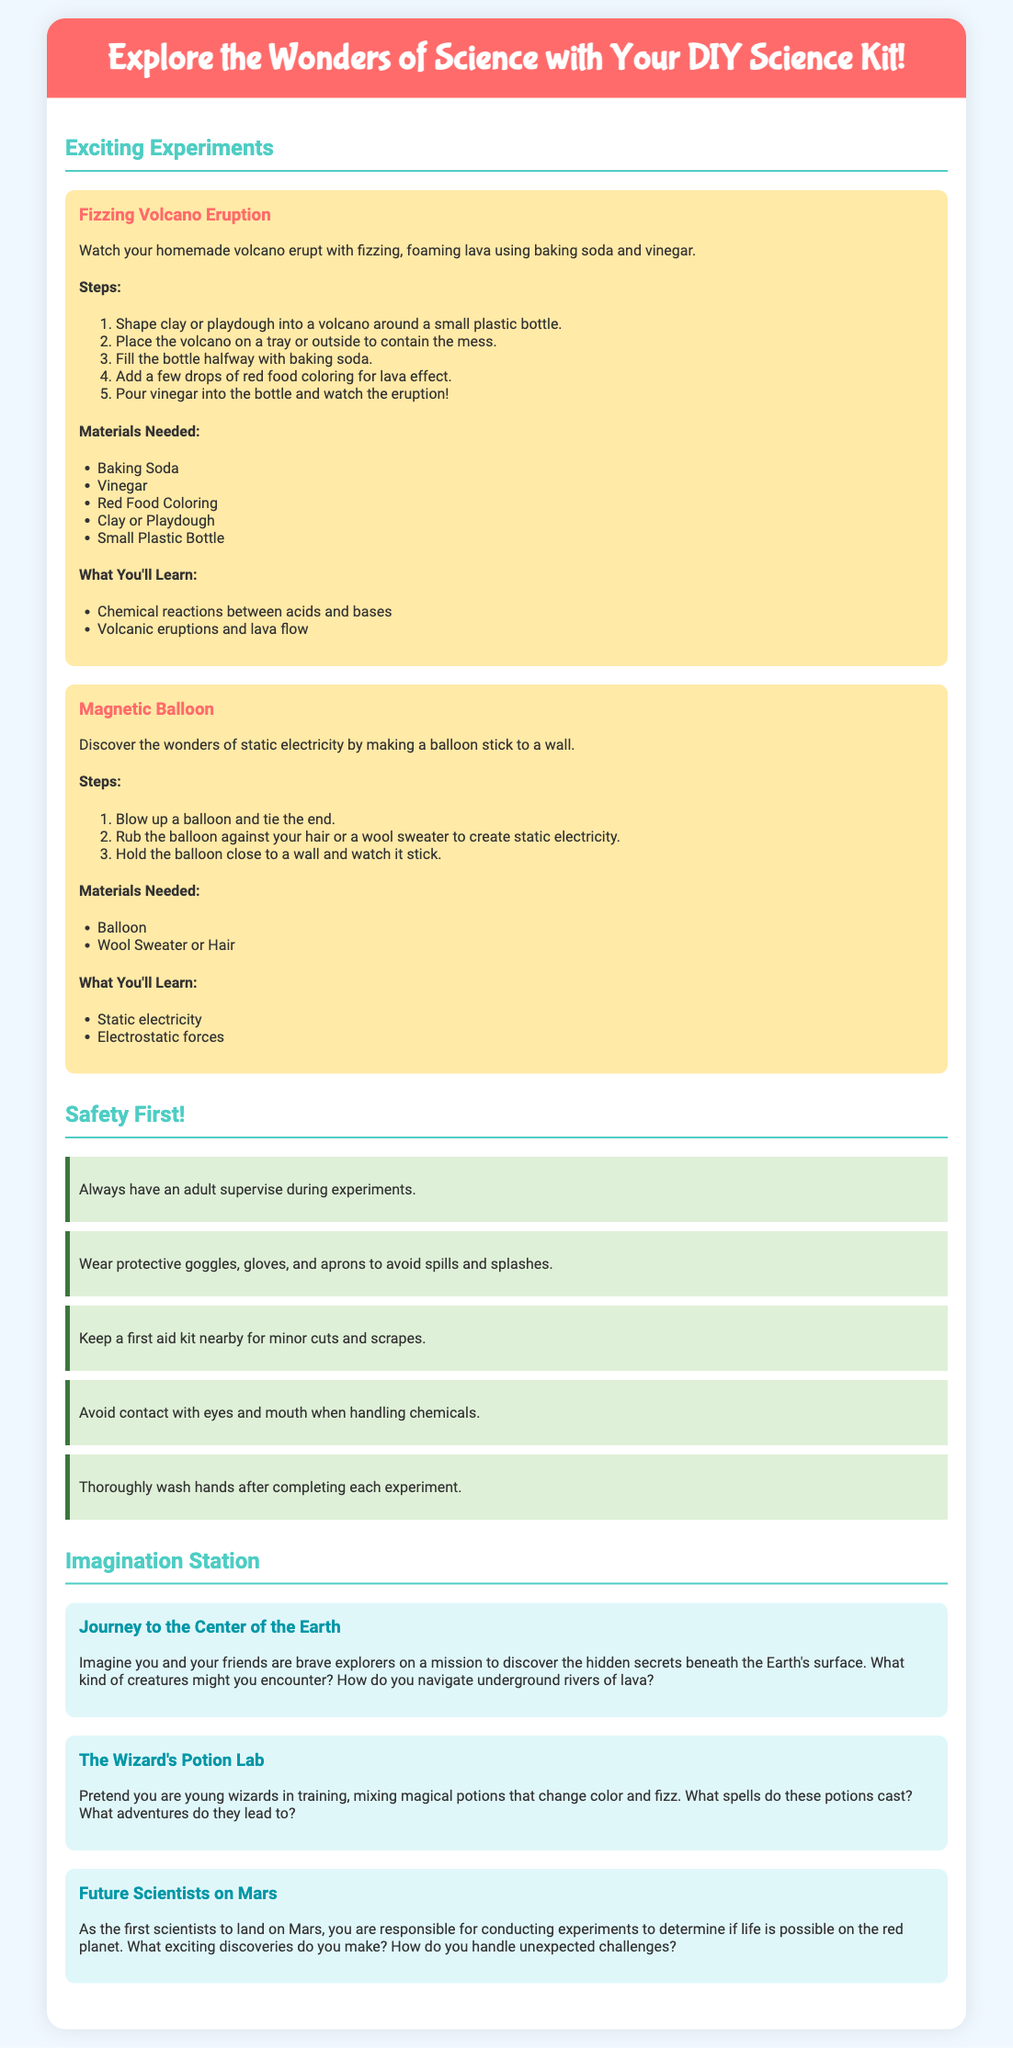What is the title of the document? The title is found in the header of the document and introduces the subject matter of the content.
Answer: Explore the Wonders of Science with Your DIY Science Kit! How many exciting experiments are listed? The total number of experiments can be counted from the "Exciting Experiments" section of the document.
Answer: 2 What is one material needed for the Fizzing Volcano Eruption? The materials are listed in the Fizzing Volcano Eruption experiment section, specifically for creating the volcano effect.
Answer: Baking Soda What should you wear to ensure safety during experiments? The safety guidelines mention specific protective gear to prevent accidents during the experiments.
Answer: Protective goggles, gloves, and aprons What imaginative story involves Mars? The document provides a list of imaginative story prompts, and one is specifically about Mars.
Answer: Future Scientists on Mars What do you learn from the Magnetic Balloon experiment? The learning outcomes are listed in the respective experiment section under "What You'll Learn."
Answer: Static electricity How many safety guidelines are provided? The safety section enumerates the guidelines, and you can count them for the total.
Answer: 5 What is a key ingredient for the Magnetic Balloon experiment? The materials for the Magnetic Balloon experiment are listed, specifying what is needed for the experiment.
Answer: Balloon 